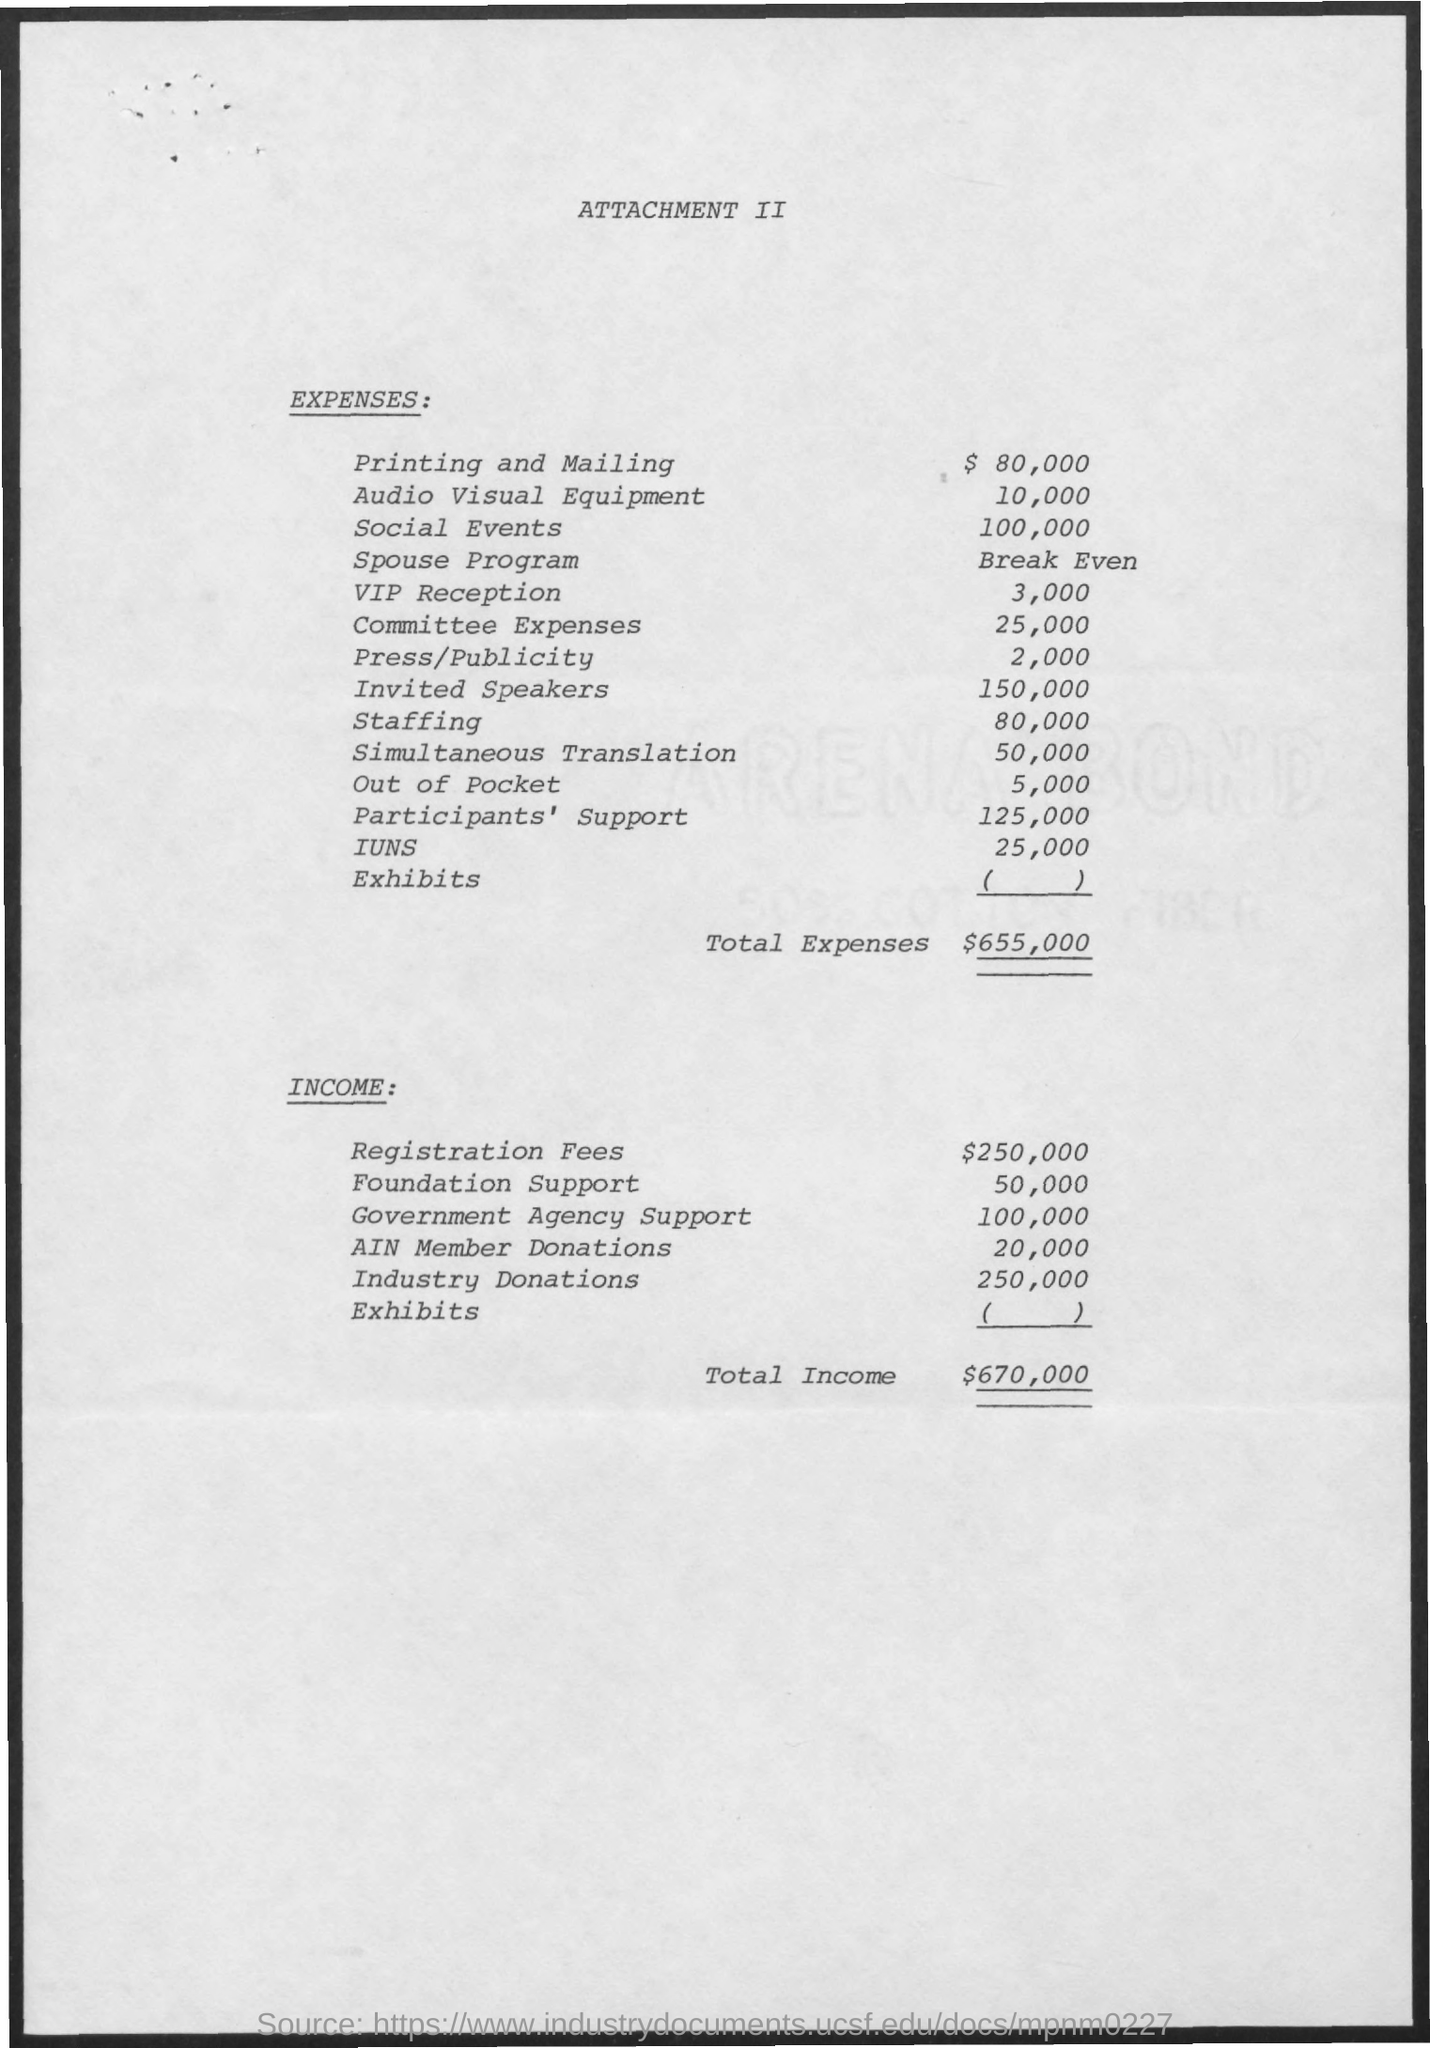Specify some key components in this picture. The expenses for staffing are approximately 80,000. The expenses for committee expenses are estimated to be $25,000. The invited speakers are the most expensive expense listed in this document. The expenses for printing and mailing are expected to total $80,000. The expenses for invited speakers are currently set at 150,000. 